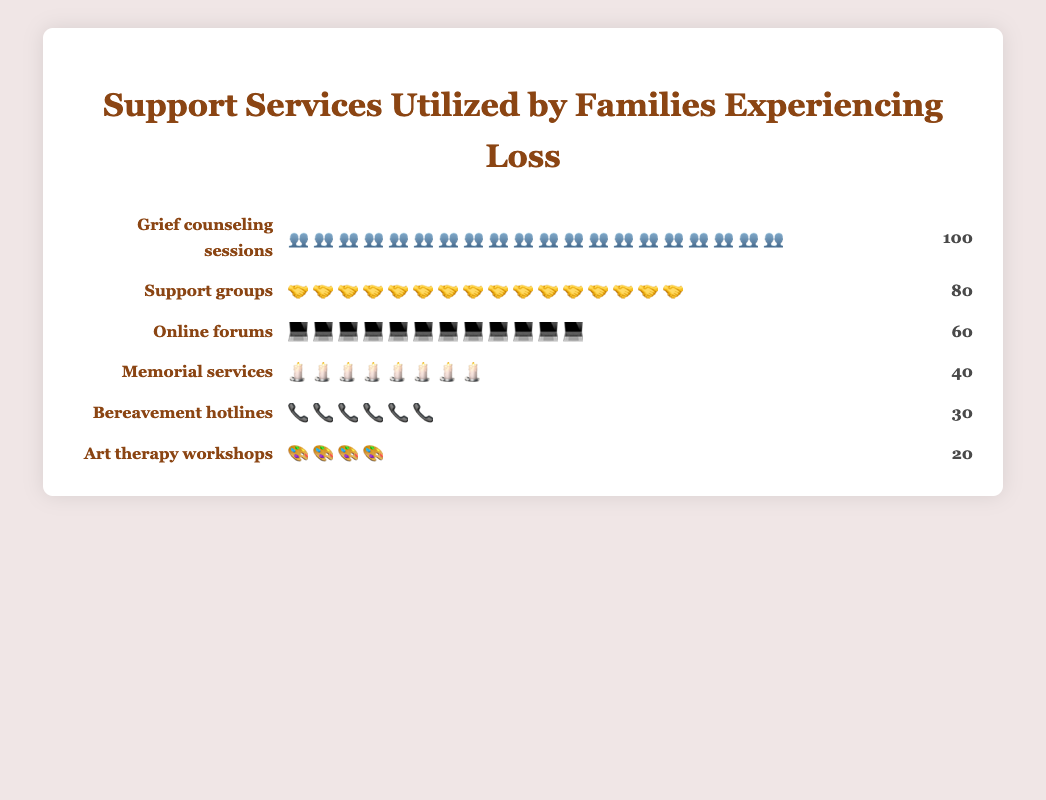What is the title of the figure? The title is clearly displayed at the top of the figure, stating the overall subject of the chart.
Answer: Support Services Utilized by Families Experiencing Loss Which support service has the highest utilization? By looking at the number of icons displayed for each service, the service with the most icons represents the highest utilization.
Answer: Grief counseling sessions How many support groups were utilized? By counting the icons in the row corresponding to "Support groups" and verifying it with the numerical count provided, the number can be determined.
Answer: 80 What is the least utilized support service? By comparing the number of icons for each service, the one with the fewest icons represents the least utilized service.
Answer: Art therapy workshops What is the total number of support services utilized by families? Sum up the counts for all the support services from the chart: 100 + 80 + 60 + 40 + 30 + 20.
Answer: 330 How many more families used grief counseling sessions compared to bereavement hotlines? Subtract the number of families using bereavement hotlines from the families using grief counseling sessions: 100 - 30.
Answer: 70 What is the average number of families using each type of support service? Calculate the average by summing the counts of all support services and dividing by the number of services: (100 + 80 + 60 + 40 + 30 + 20) / 6.
Answer: 55 How does the utilization of online forums compare to support groups? By comparing the respective counts, the utilization of online forums is less than support groups by: 80 - 60.
Answer: 20 less Which support service has exactly half the utilization of grief counseling sessions? Find the support service with a count that is half of 100: 100 / 2 = 50. None of the services have exactly half, but memorial services come closest with a count of 40.
Answer: Memorial services How many more families used support groups over art therapy workshops? Subtract the number of families using art therapy workshops from the number using support groups: 80 - 20.
Answer: 60 